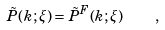Convert formula to latex. <formula><loc_0><loc_0><loc_500><loc_500>\tilde { P } ( { k } ; \xi ) = \tilde { P } ^ { F } ( { k } ; \xi ) \quad ,</formula> 